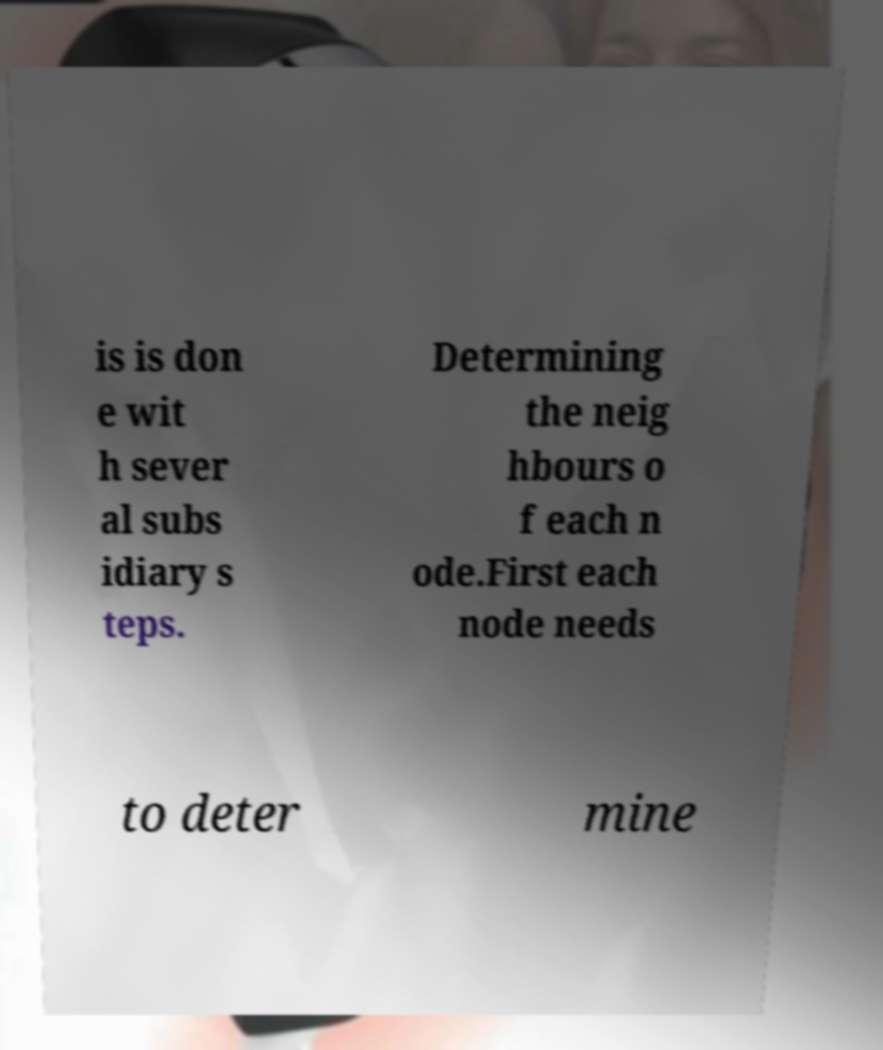I need the written content from this picture converted into text. Can you do that? is is don e wit h sever al subs idiary s teps. Determining the neig hbours o f each n ode.First each node needs to deter mine 